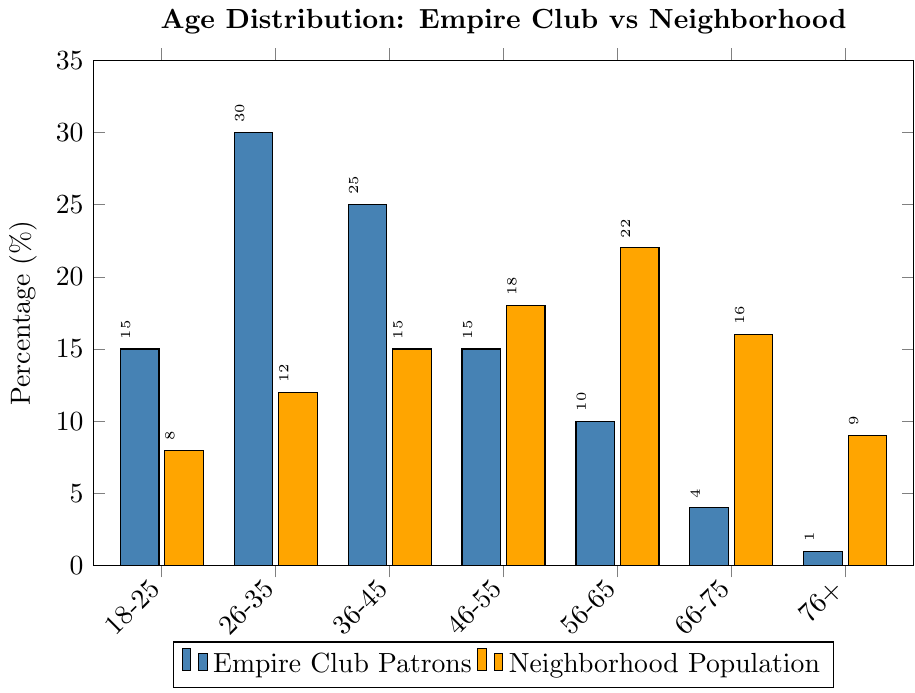What's the age group with the most patrons at the Empire Club? The Empire Club has the highest percentage of patrons in the age group 26-35, with 30% of patrons falling within this group.
Answer: 26-35 How does the percentage of patrons aged 36-45 at the Empire Club compare to the neighborhood's population of the same age group? The percentage of patrons aged 36-45 at the Empire Club is 25%, while the neighborhood's population for this age group is 15%. The Empire Club has a higher percentage.
Answer: The Empire Club has a higher percentage What is the combined percentage of Empire Club patrons aged 56-65 and 66-75? The percentage of patrons aged 56-65 is 10%, and for 66-75, it is 4%. Their combined percentage is 10% + 4% = 14%.
Answer: 14% In terms of percentage, which age group is more represented in the neighborhood compared to the Empire Club? The age group 56-65 is more represented in the neighborhood (22%) compared to the Empire Club (10%).
Answer: 56-65 What is the difference in the percentage of patrons aged 76+ between the Empire Club and the neighborhood? The percentage of patrons aged 76+ at the Empire Club is 1%, while the neighborhood's population for this age group is 9%. The difference is 9% - 1% = 8%.
Answer: 8% Looking at the bar colors, which color represents the Empire Club patrons and which color represents the neighborhood population? The color representing the Empire Club patrons is blue, and the color representing the neighborhood population is orange.
Answer: Blue for Empire Club, Orange for Neighborhood What percentage of Empire Club patrons are under 25 years old? The percentage of Empire Club patrons aged 18-25 is directly given as 15%.
Answer: 15% Among the age groups 46-55 and 66-75, which has more patrons in the Empire Club? The age group 46-55 has 15% of the Empire Club patrons, while the age group 66-75 has 4%. Therefore, there are more patrons aged 46-55.
Answer: 46-55 What is the average percentage of patrons in the 36-45 and 46-55 age groups at the Empire Club? The percentage of patrons aged 36-45 is 25% and for 46-55 is 15%. The average is (25% + 15%) / 2 = 20%.
Answer: 20% Which age group shows the greatest discrepancy in percentage between the Empire Club patrons and the neighborhood population? The age group 26-35 has the greatest discrepancy, with 30% at the Empire Club and 12% in the neighborhood, a difference of 18%.
Answer: 26-35 